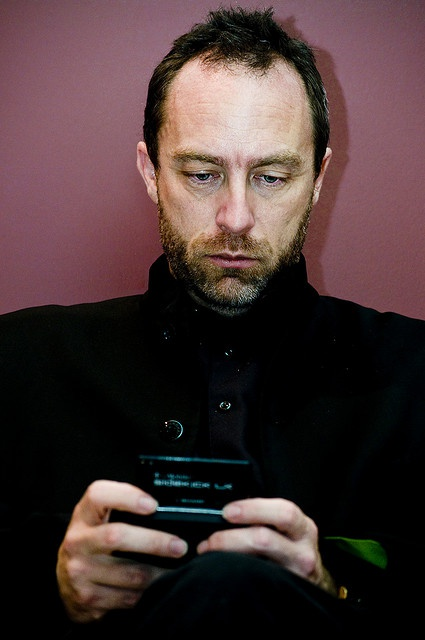Describe the objects in this image and their specific colors. I can see people in black, brown, tan, gray, and lightgray tones and cell phone in brown, black, teal, and maroon tones in this image. 